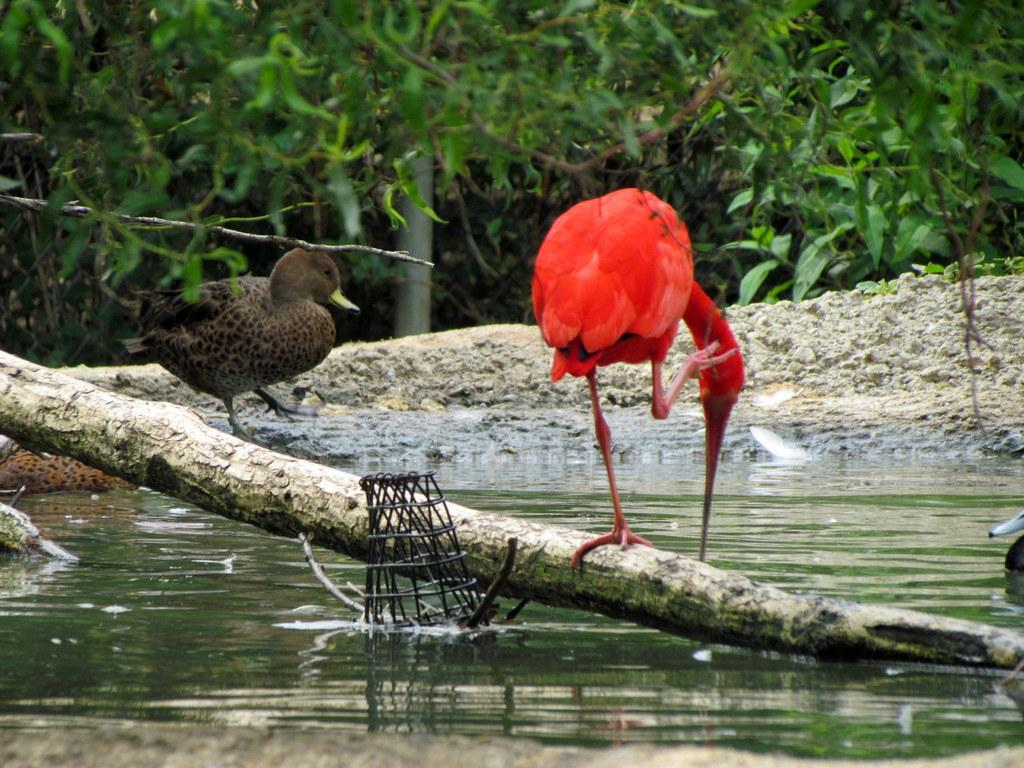What type of animals can be seen in the image? There are birds in the image. What is the tree trunk's location in the image? The tree trunk is in the water in the image. What else can be found in the water in the image? There is an object in the water in the image. What type of vegetation is visible in the image? There are trees visible in the image. What type of nail can be seen in the image? There is no nail present in the image. How many snakes are visible in the image? There are no snakes visible in the image. 